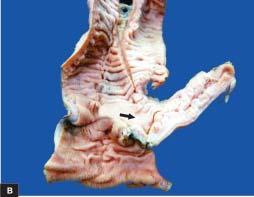does the lumen contain necrotic debris?
Answer the question using a single word or phrase. Yes 